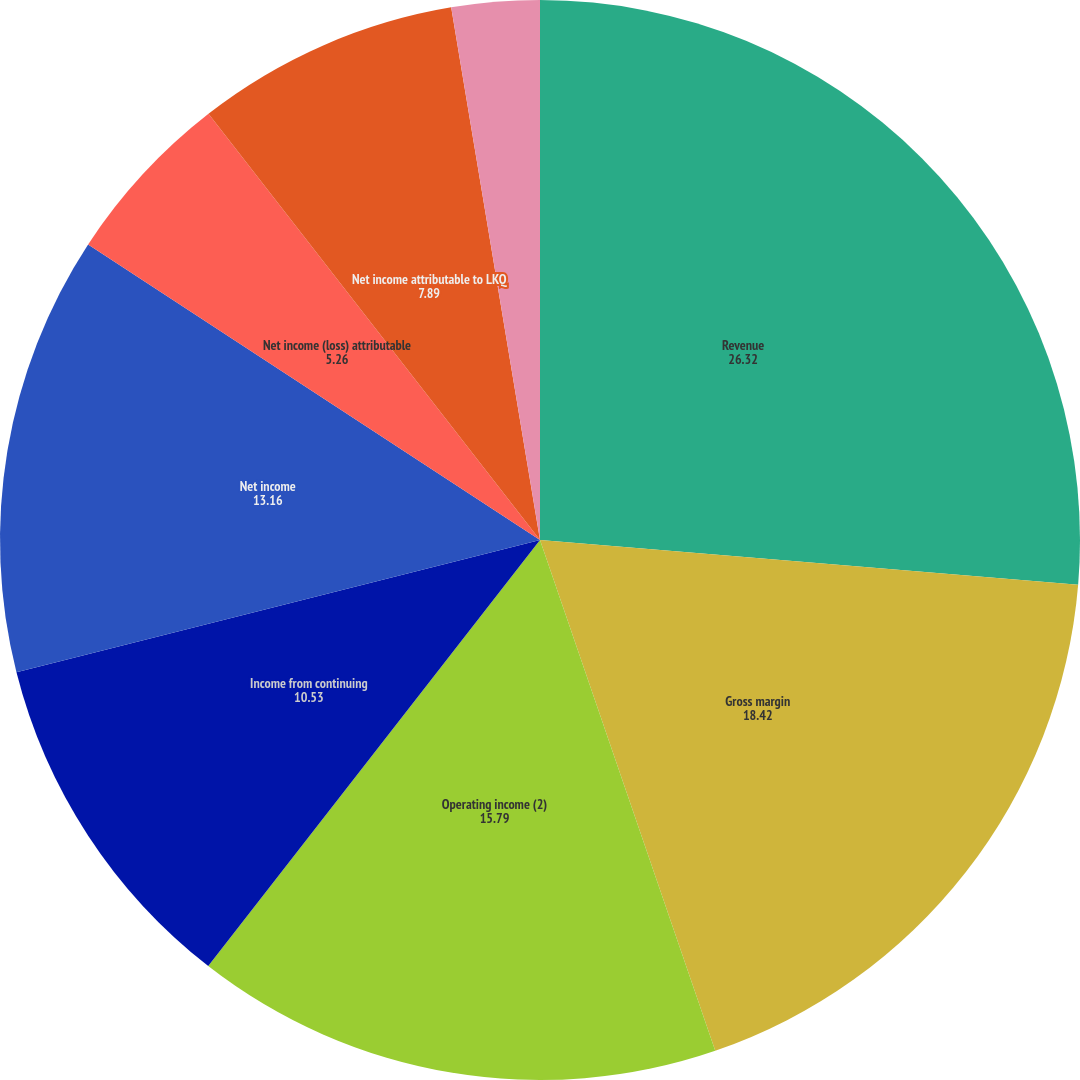Convert chart to OTSL. <chart><loc_0><loc_0><loc_500><loc_500><pie_chart><fcel>Revenue<fcel>Gross margin<fcel>Operating income (2)<fcel>Income from continuing<fcel>Net income<fcel>Net income (loss) attributable<fcel>Net income attributable to LKQ<fcel>Basic earnings per share from<fcel>Diluted earnings per share<nl><fcel>26.32%<fcel>18.42%<fcel>15.79%<fcel>10.53%<fcel>13.16%<fcel>5.26%<fcel>7.89%<fcel>2.63%<fcel>0.0%<nl></chart> 